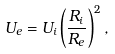Convert formula to latex. <formula><loc_0><loc_0><loc_500><loc_500>U _ { e } = U _ { i } \left ( \frac { R _ { i } } { R _ { e } } \right ) ^ { 2 } ,</formula> 